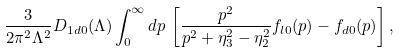<formula> <loc_0><loc_0><loc_500><loc_500>\frac { 3 } { 2 \pi ^ { 2 } \Lambda ^ { 2 } } D _ { 1 d 0 } ( \Lambda ) \int _ { 0 } ^ { \infty } d p \, \left [ \frac { p ^ { 2 } } { p ^ { 2 } + \eta _ { 3 } ^ { 2 } - \eta _ { 2 } ^ { 2 } } f _ { l 0 } ( p ) - f _ { d 0 } ( p ) \right ] ,</formula> 